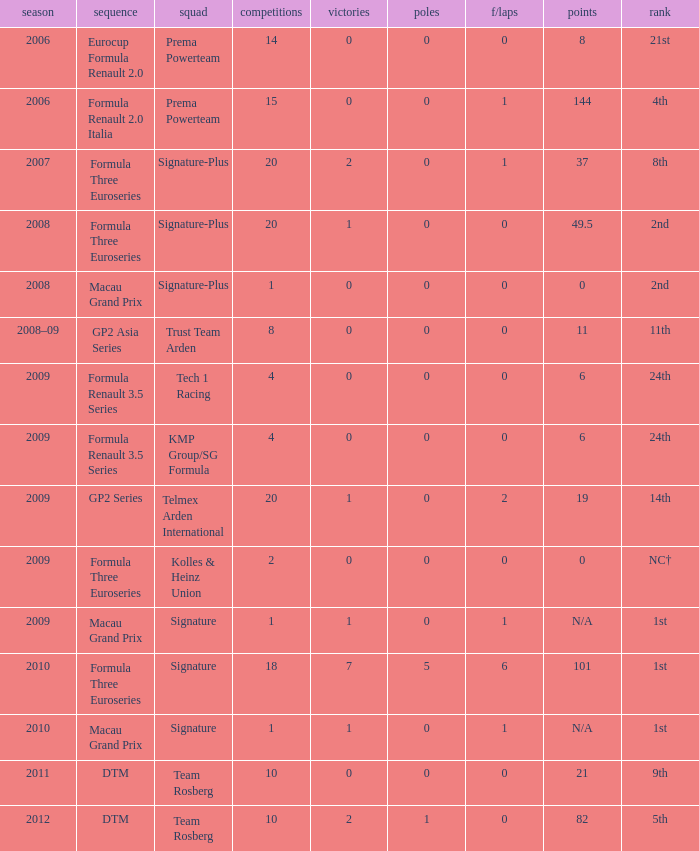How many poles are there in the 2009 season with 2 races and more than 0 F/Laps? 0.0. 